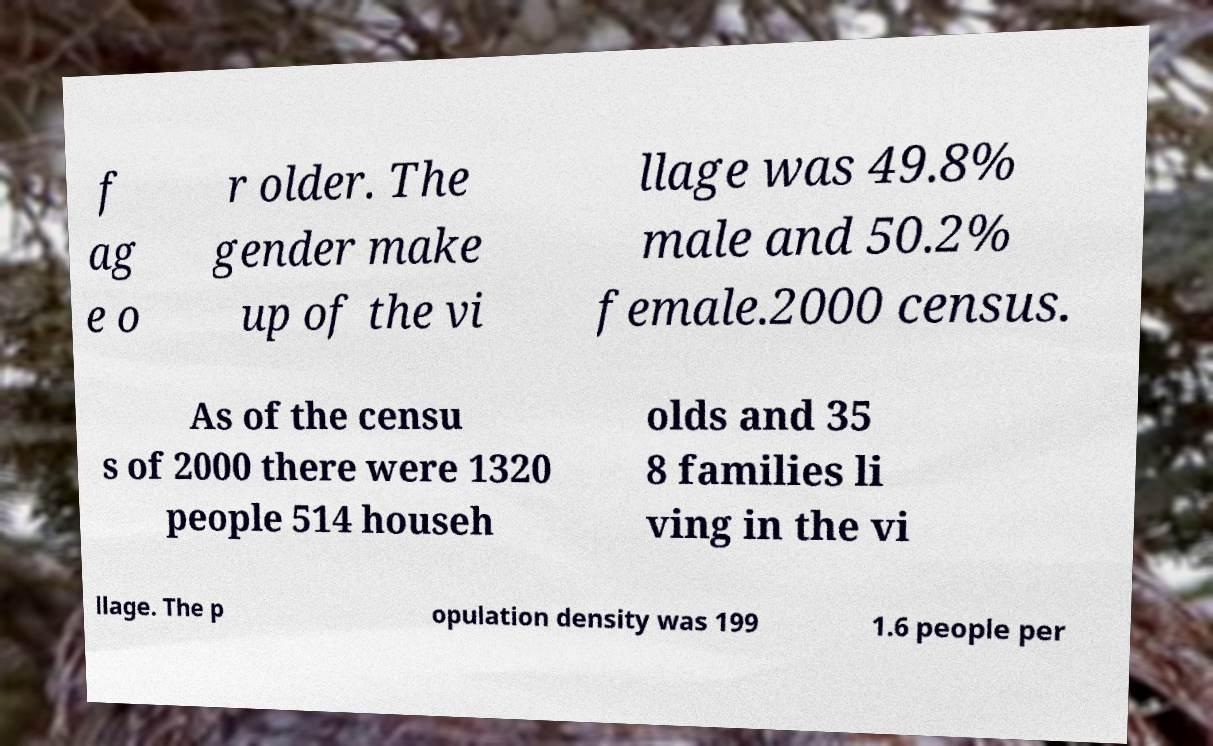Please identify and transcribe the text found in this image. f ag e o r older. The gender make up of the vi llage was 49.8% male and 50.2% female.2000 census. As of the censu s of 2000 there were 1320 people 514 househ olds and 35 8 families li ving in the vi llage. The p opulation density was 199 1.6 people per 